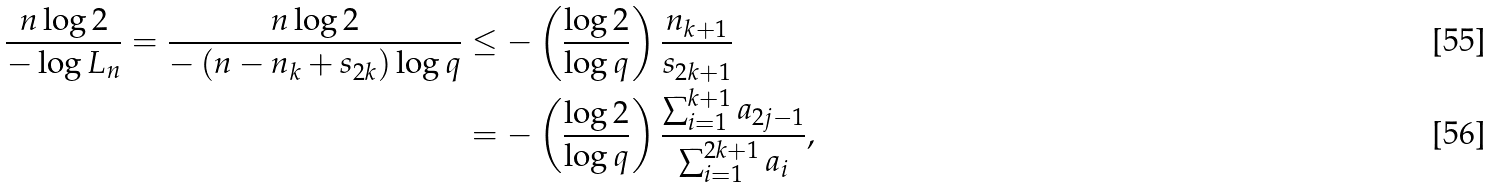Convert formula to latex. <formula><loc_0><loc_0><loc_500><loc_500>\frac { n \log 2 } { - \log L _ { n } } = \frac { n \log 2 } { - \left ( n - n _ { k } + s _ { 2 k } \right ) \log q } & \leq - \left ( \frac { \log 2 } { \log q } \right ) \frac { n _ { k + 1 } } { s _ { 2 k + 1 } } \\ & = - \left ( \frac { \log 2 } { \log q } \right ) \frac { \sum _ { i = 1 } ^ { k + 1 } a _ { 2 j - 1 } } { \sum _ { i = 1 } ^ { 2 k + 1 } a _ { i } } ,</formula> 